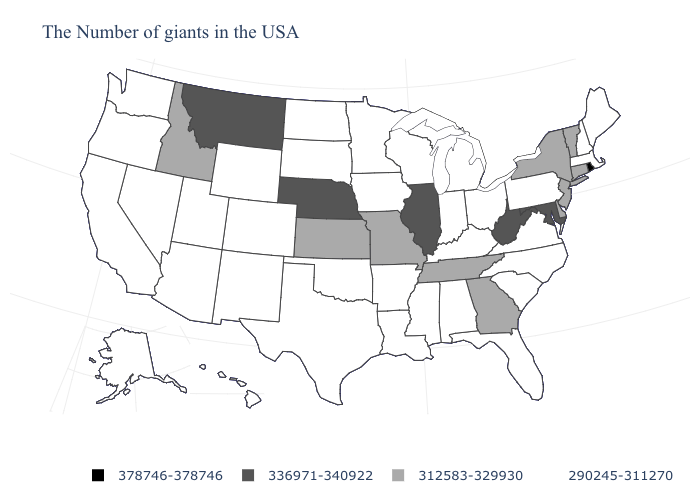Name the states that have a value in the range 290245-311270?
Short answer required. Maine, Massachusetts, New Hampshire, Pennsylvania, Virginia, North Carolina, South Carolina, Ohio, Florida, Michigan, Kentucky, Indiana, Alabama, Wisconsin, Mississippi, Louisiana, Arkansas, Minnesota, Iowa, Oklahoma, Texas, South Dakota, North Dakota, Wyoming, Colorado, New Mexico, Utah, Arizona, Nevada, California, Washington, Oregon, Alaska, Hawaii. Does the map have missing data?
Quick response, please. No. What is the highest value in states that border Maryland?
Quick response, please. 336971-340922. Does Iowa have the lowest value in the MidWest?
Write a very short answer. Yes. Among the states that border Pennsylvania , does New Jersey have the highest value?
Give a very brief answer. No. Among the states that border North Dakota , which have the highest value?
Short answer required. Montana. Does Montana have a lower value than Rhode Island?
Write a very short answer. Yes. Name the states that have a value in the range 336971-340922?
Give a very brief answer. Maryland, West Virginia, Illinois, Nebraska, Montana. Does the first symbol in the legend represent the smallest category?
Keep it brief. No. Does the first symbol in the legend represent the smallest category?
Give a very brief answer. No. Does Delaware have a higher value than North Dakota?
Keep it brief. Yes. Name the states that have a value in the range 290245-311270?
Be succinct. Maine, Massachusetts, New Hampshire, Pennsylvania, Virginia, North Carolina, South Carolina, Ohio, Florida, Michigan, Kentucky, Indiana, Alabama, Wisconsin, Mississippi, Louisiana, Arkansas, Minnesota, Iowa, Oklahoma, Texas, South Dakota, North Dakota, Wyoming, Colorado, New Mexico, Utah, Arizona, Nevada, California, Washington, Oregon, Alaska, Hawaii. Does the map have missing data?
Concise answer only. No. What is the value of Indiana?
Concise answer only. 290245-311270. 